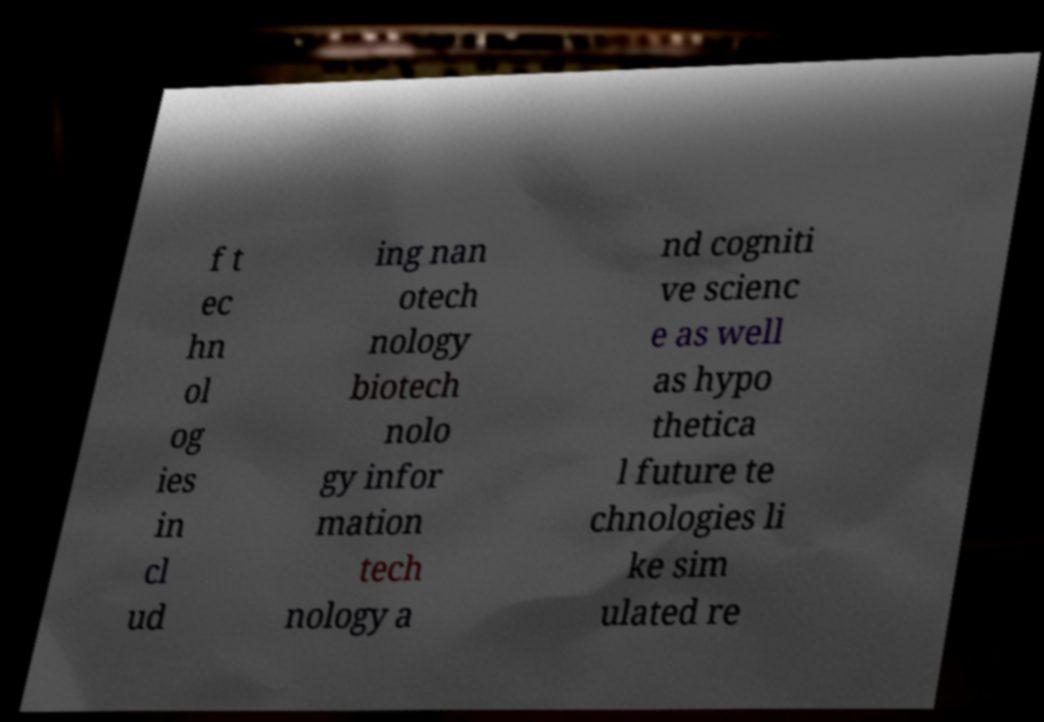Please identify and transcribe the text found in this image. f t ec hn ol og ies in cl ud ing nan otech nology biotech nolo gy infor mation tech nology a nd cogniti ve scienc e as well as hypo thetica l future te chnologies li ke sim ulated re 